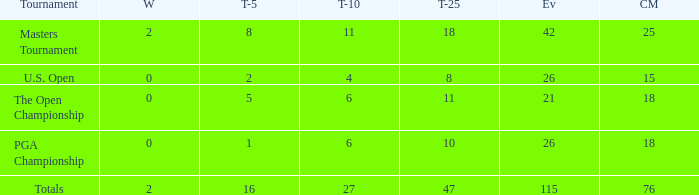When there are less than 0 wins and a top-5 of 1, what is the average amount of cuts? None. 